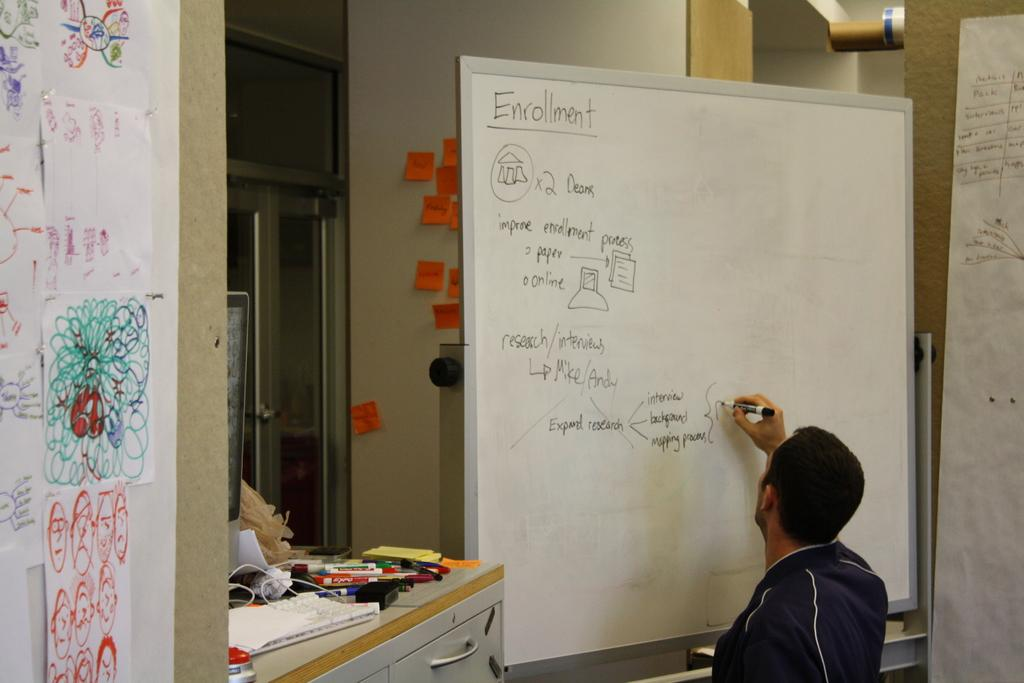<image>
Create a compact narrative representing the image presented. A white board has the heading enrollment on the top. 